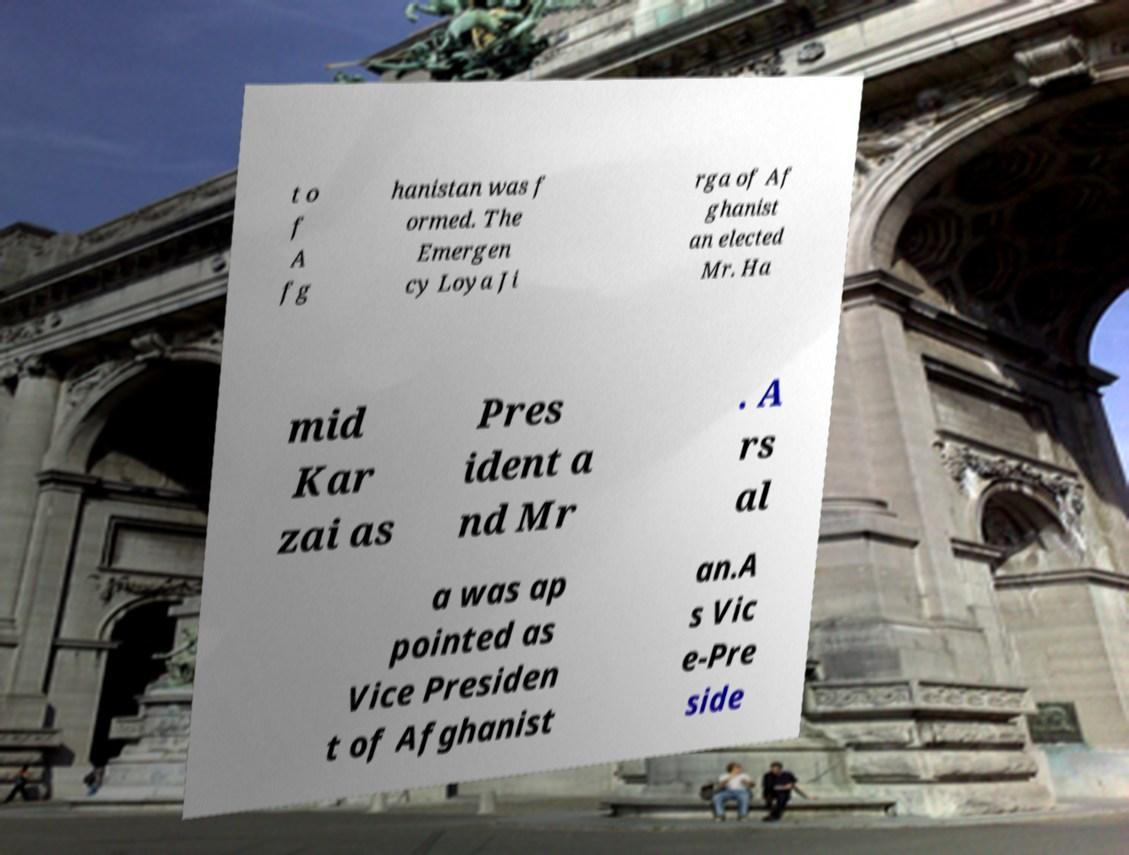Can you accurately transcribe the text from the provided image for me? t o f A fg hanistan was f ormed. The Emergen cy Loya Ji rga of Af ghanist an elected Mr. Ha mid Kar zai as Pres ident a nd Mr . A rs al a was ap pointed as Vice Presiden t of Afghanist an.A s Vic e-Pre side 